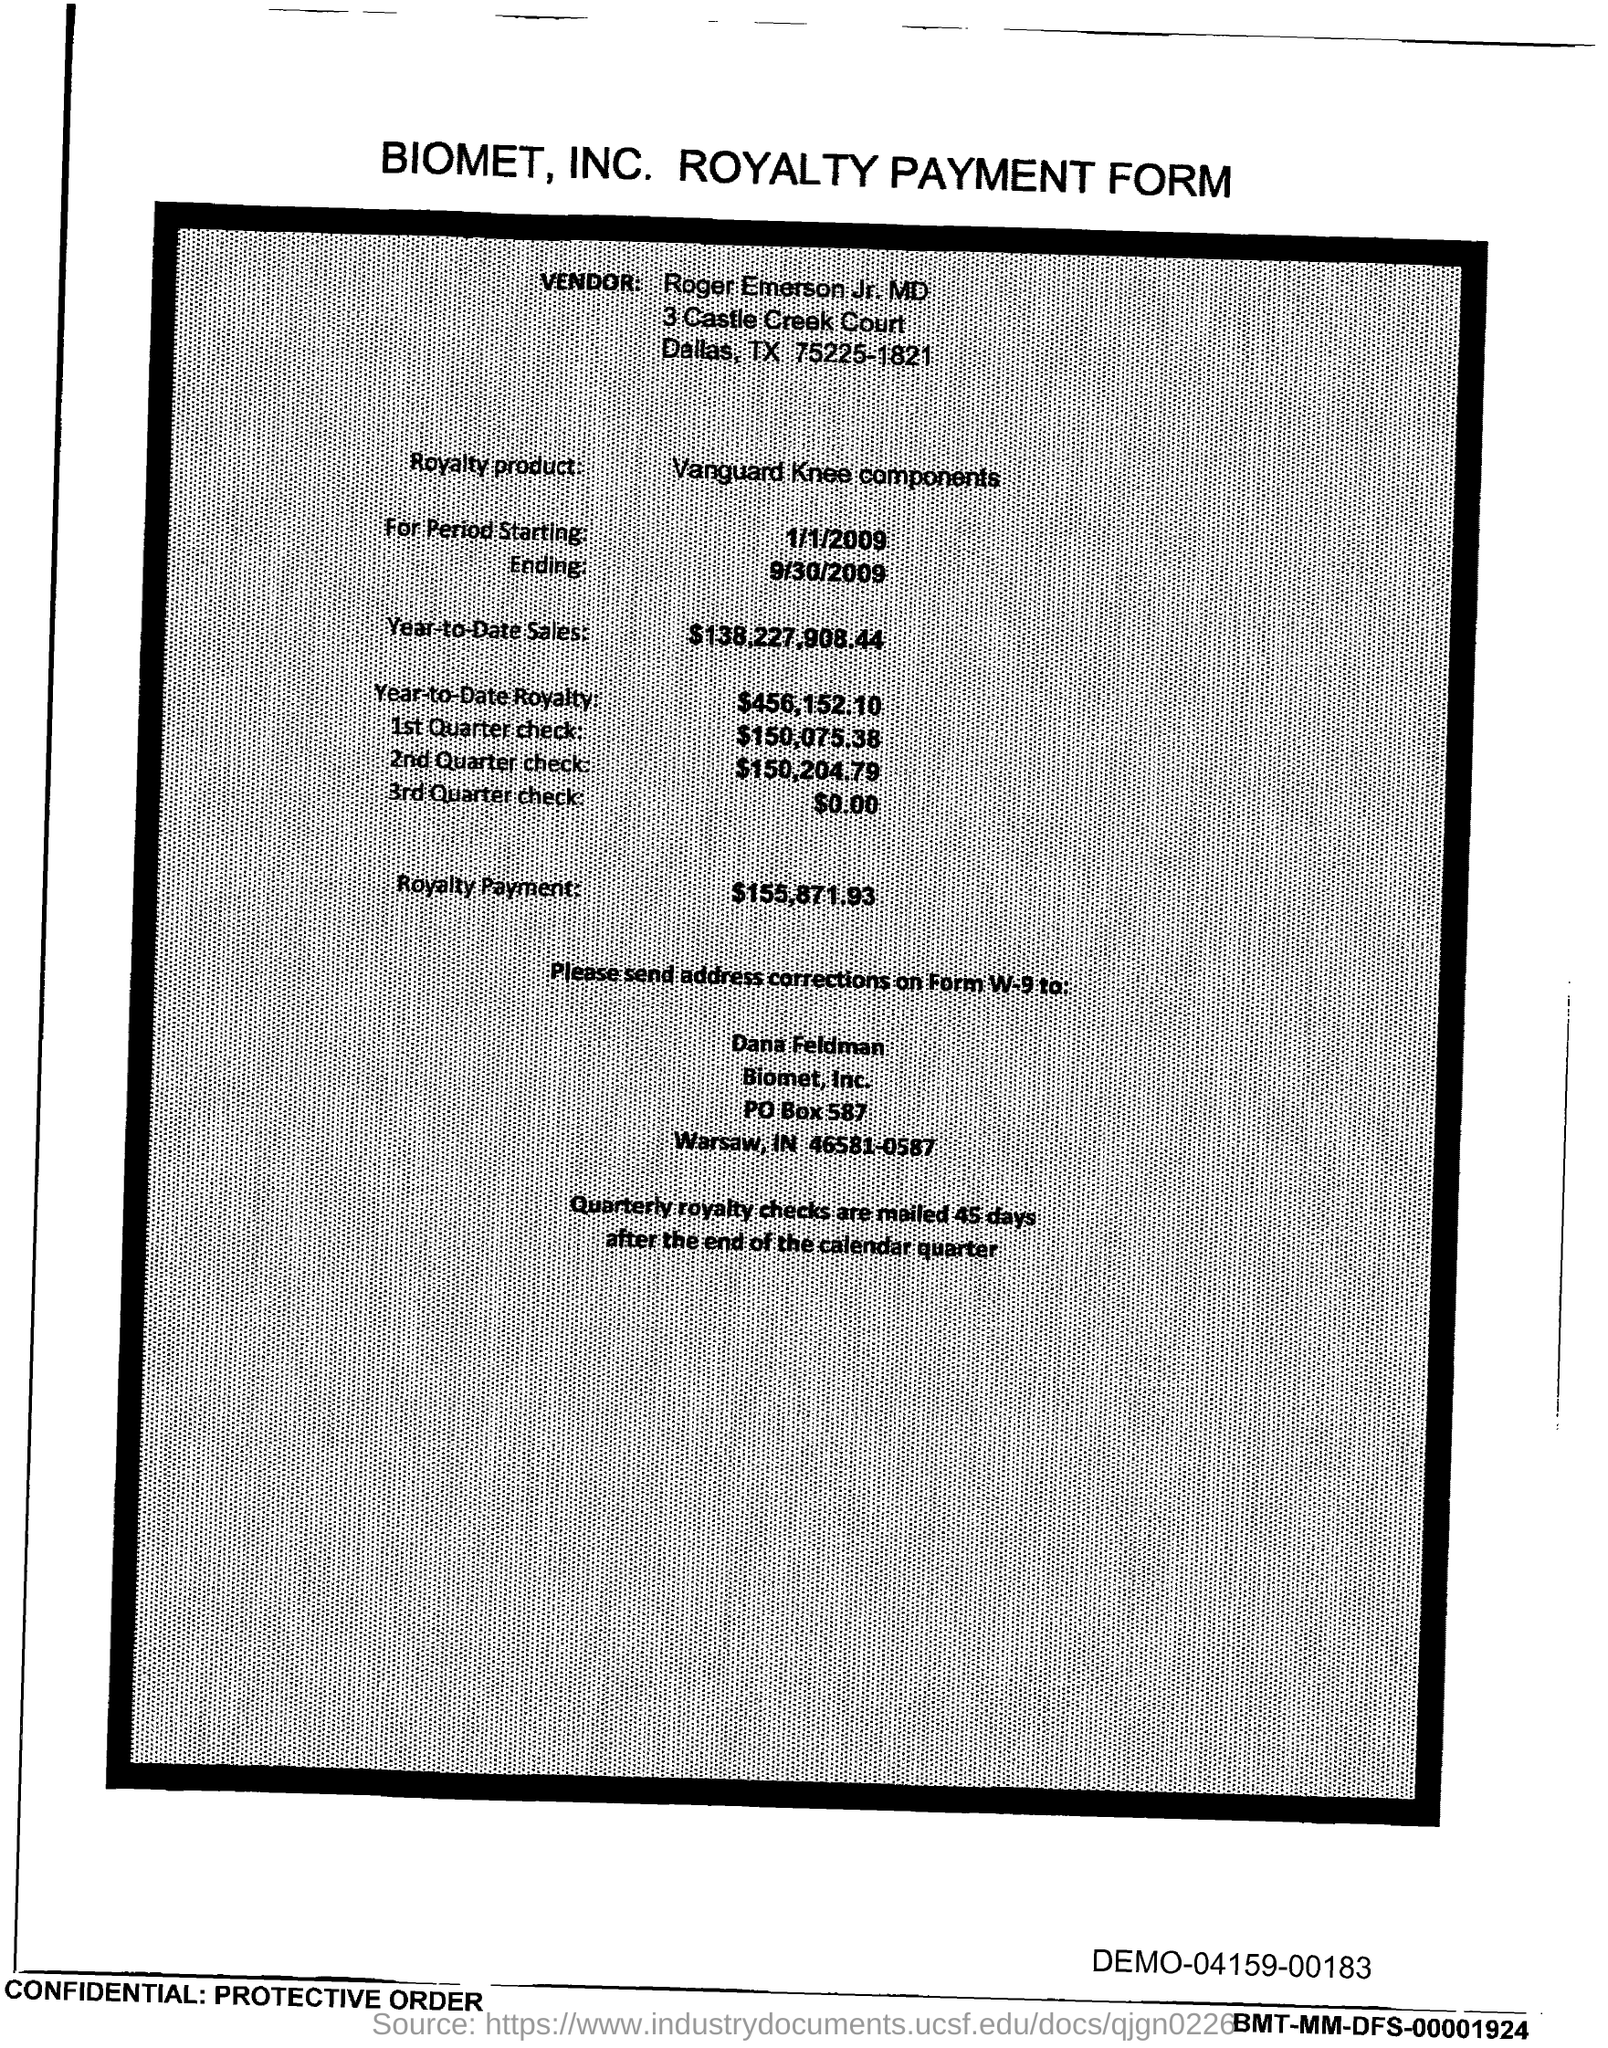What is the PO Box Number mentioned in the document?
Make the answer very short. 587. 